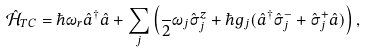Convert formula to latex. <formula><loc_0><loc_0><loc_500><loc_500>\hat { \mathcal { H } } _ { T C } = \hbar { \omega } _ { r } \hat { a } ^ { \dagger } \hat { a } + \sum _ { j } { \left ( \frac { } { 2 } \omega _ { j } \hat { \sigma } ^ { z } _ { j } + \hbar { g } _ { j } ( \hat { a } ^ { \dagger } \hat { \sigma } ^ { - } _ { j } + \hat { \sigma } ^ { + } _ { j } \hat { a } ) \right ) } \, ,</formula> 